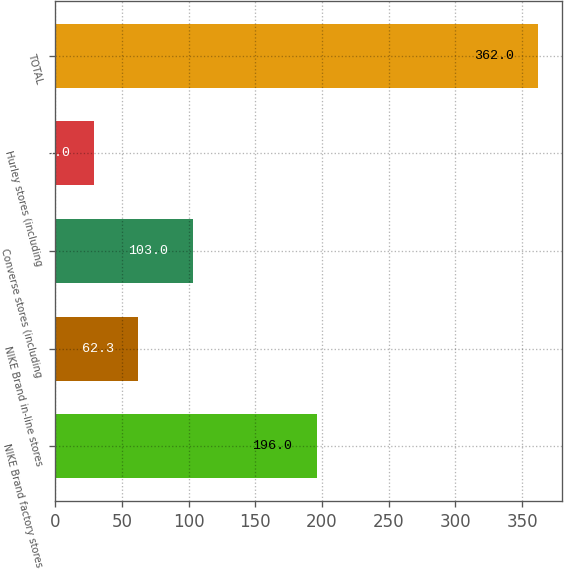Convert chart to OTSL. <chart><loc_0><loc_0><loc_500><loc_500><bar_chart><fcel>NIKE Brand factory stores<fcel>NIKE Brand in-line stores<fcel>Converse stores (including<fcel>Hurley stores (including<fcel>TOTAL<nl><fcel>196<fcel>62.3<fcel>103<fcel>29<fcel>362<nl></chart> 